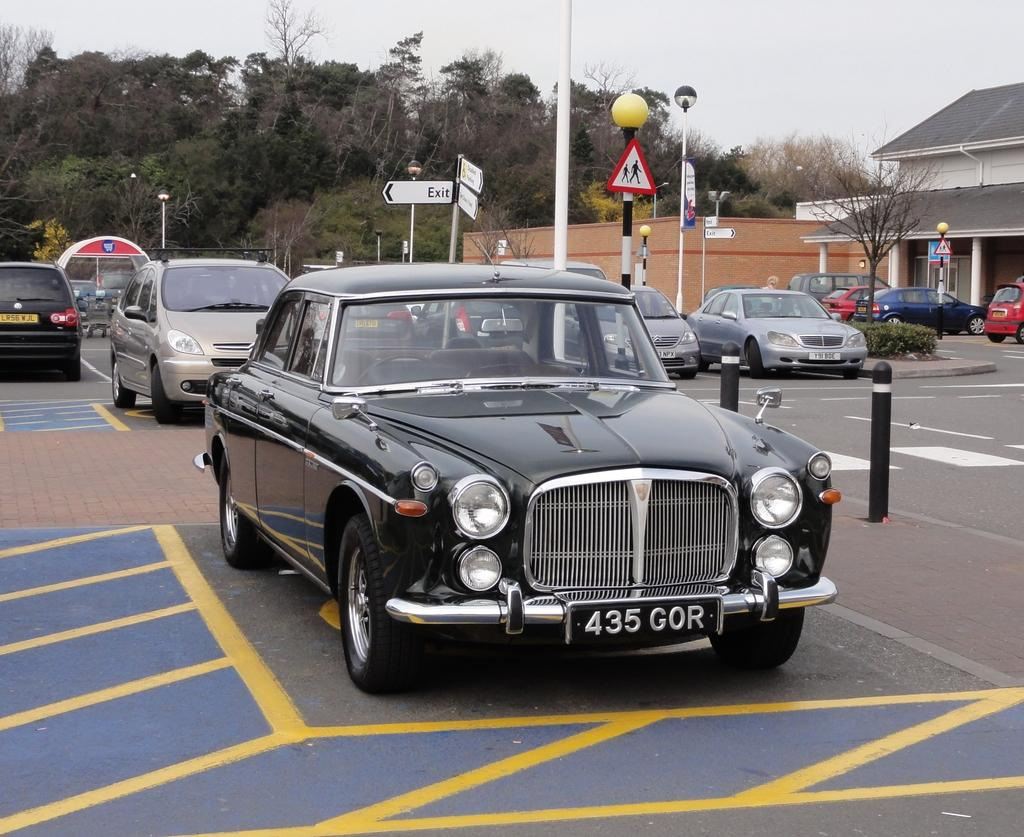What can be seen in the image that is used for transportation? There are vehicles parked in the image. What structures are located in the right corner of the image? There are two buildings in the right corner of the image. What type of natural elements can be seen in the background of the image? There are trees in the background of the image. What type of liquid is being controlled by the spark in the image? There is no liquid or spark present in the image. How does the control system work for the vehicles in the image? The image does not provide information about the control system for the vehicles. 